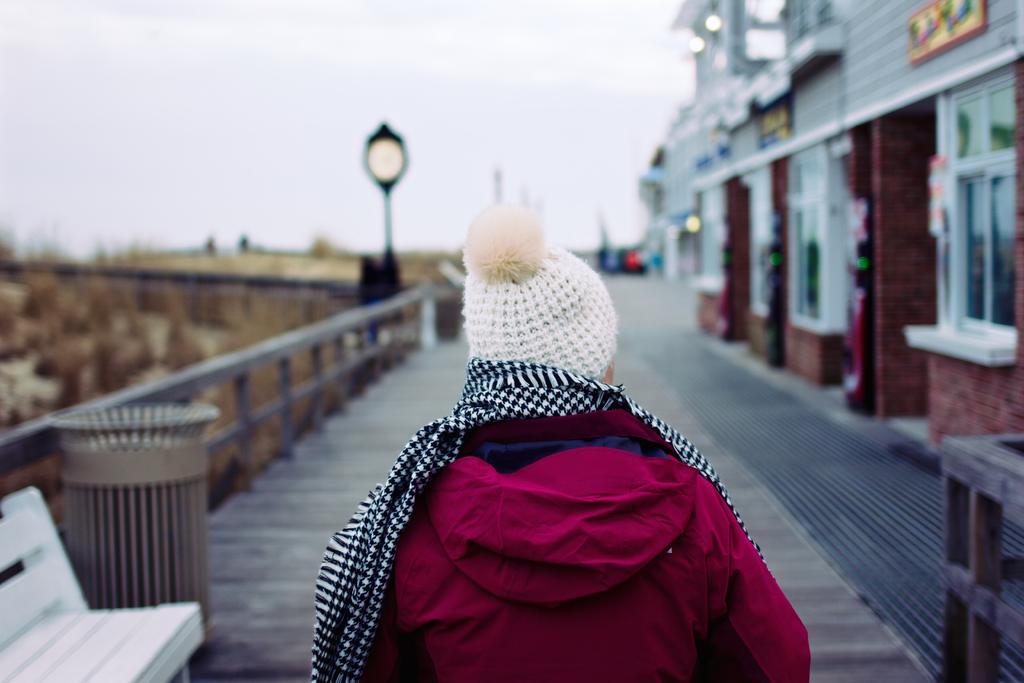Please provide a concise description of this image. In the center of the image there is a person on the ground. On the right side of the image we can see building. On the left side of the image we can see plants, dustbin, bench and light. In the background there is sky. 